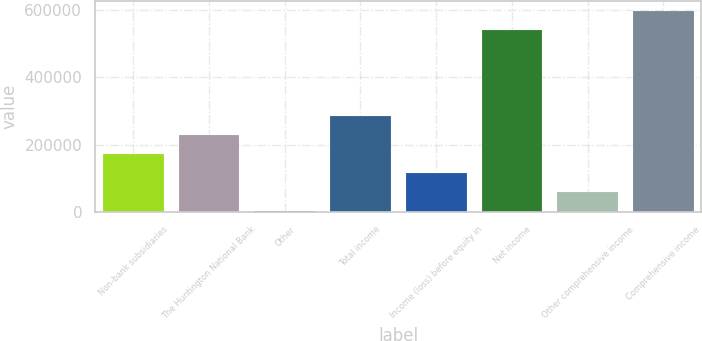<chart> <loc_0><loc_0><loc_500><loc_500><bar_chart><fcel>Non-bank subsidiaries<fcel>The Huntington National Bank<fcel>Other<fcel>Total income<fcel>Income (loss) before equity in<fcel>Net income<fcel>Other comprehensive income<fcel>Comprehensive income<nl><fcel>170766<fcel>227277<fcel>1231<fcel>283788<fcel>114254<fcel>542613<fcel>57742.5<fcel>599124<nl></chart> 